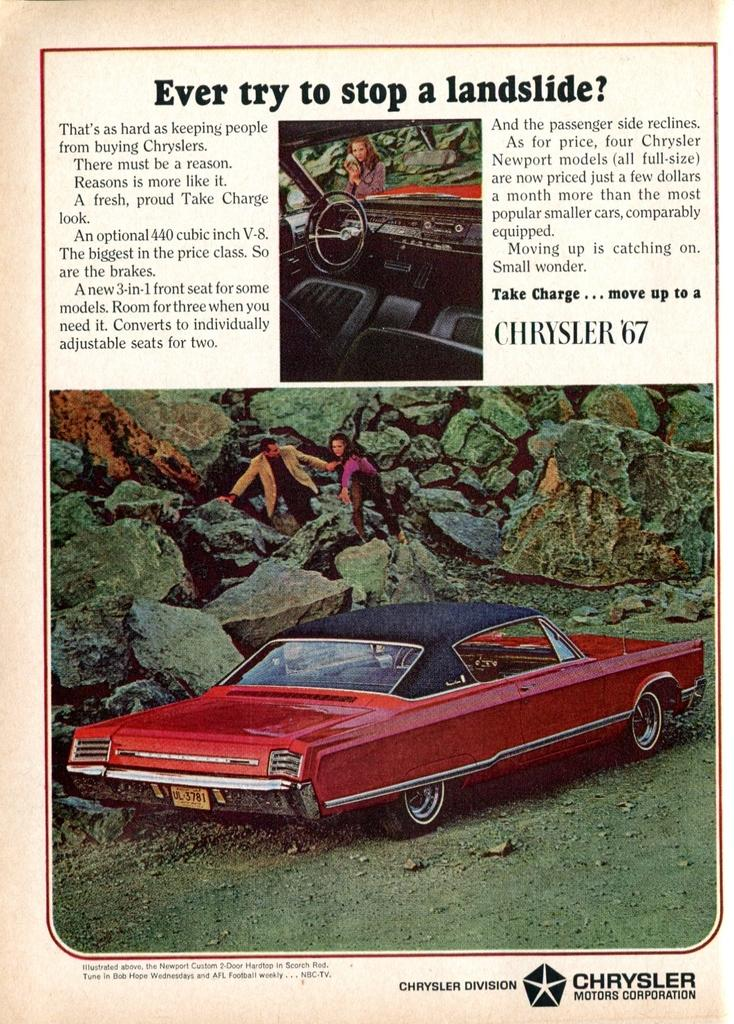What is the main subject of the image? The main subject of the image is an article. What can be found within the article? There are pictures in the article. What can be seen in the pictures? In the pictures, there are people, vehicles, seats, steering wheels, and rocks. How many women are smiling in the image? There is no information about women or smiling in the image; it contains an article with pictures of people, vehicles, seats, steering wheels, and rocks. 